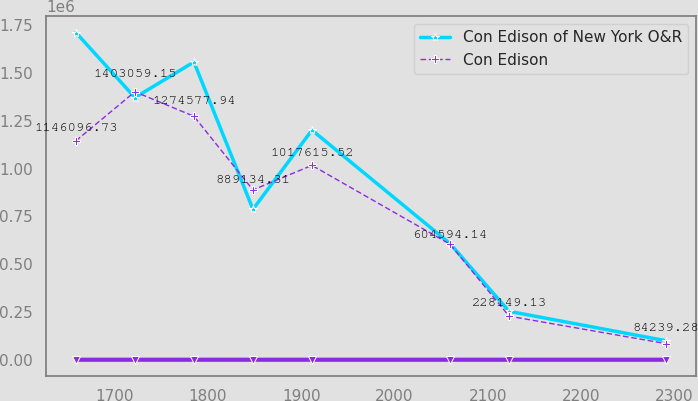Convert chart. <chart><loc_0><loc_0><loc_500><loc_500><line_chart><ecel><fcel>Unnamed: 1<fcel>Con Edison of New York O&R<fcel>Con Edison<nl><fcel>1658.53<fcel>7.55<fcel>1.71303e+06<fcel>1.1461e+06<nl><fcel>1721.8<fcel>8.13<fcel>1.37255e+06<fcel>1.40306e+06<nl><fcel>1785.07<fcel>6.97<fcel>1.55891e+06<fcel>1.27458e+06<nl><fcel>1848.34<fcel>5.81<fcel>787588<fcel>889134<nl><fcel>1911.61<fcel>6.39<fcel>1.20209e+06<fcel>1.01762e+06<nl><fcel>2059.64<fcel>3.89<fcel>607876<fcel>604594<nl><fcel>2122.91<fcel>3.09<fcel>253445<fcel>228149<nl><fcel>2291.25<fcel>1.88<fcel>99325.9<fcel>84239.3<nl></chart> 